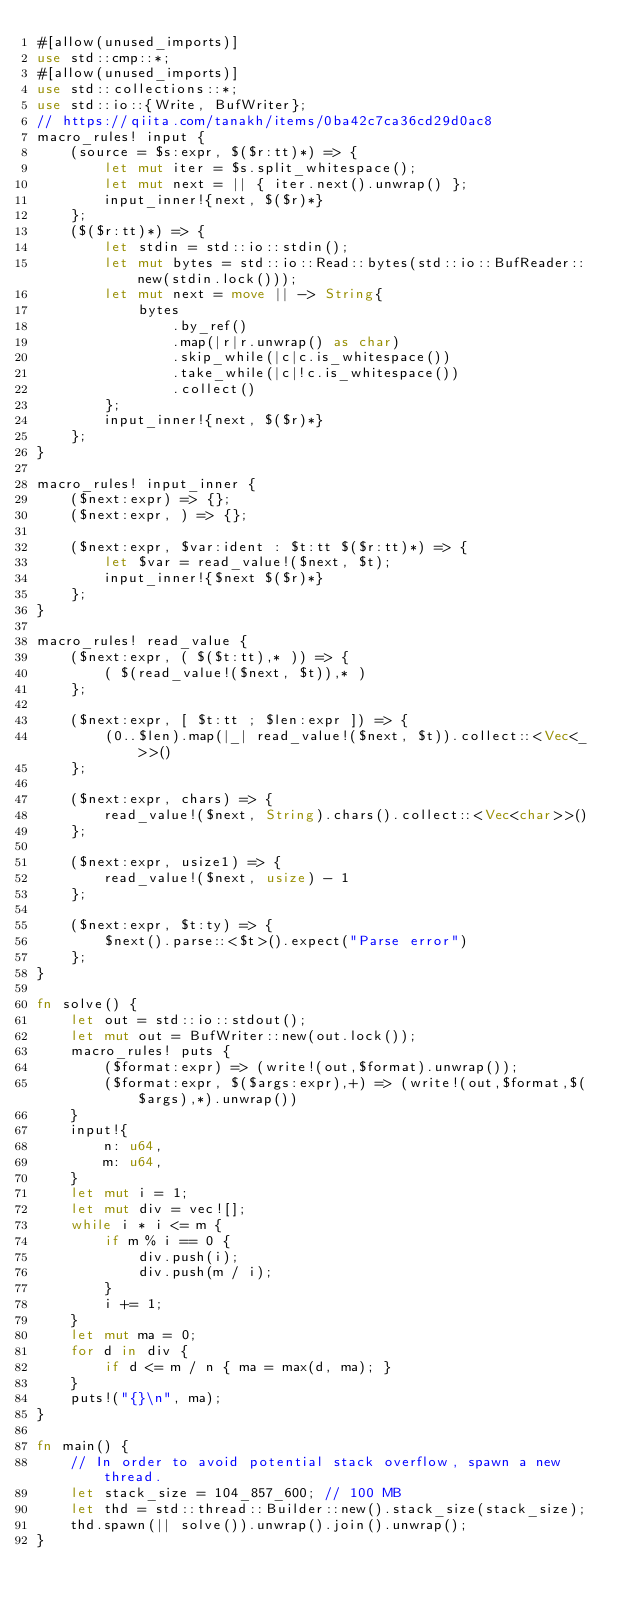Convert code to text. <code><loc_0><loc_0><loc_500><loc_500><_Rust_>#[allow(unused_imports)]
use std::cmp::*;
#[allow(unused_imports)]
use std::collections::*;
use std::io::{Write, BufWriter};
// https://qiita.com/tanakh/items/0ba42c7ca36cd29d0ac8
macro_rules! input {
    (source = $s:expr, $($r:tt)*) => {
        let mut iter = $s.split_whitespace();
        let mut next = || { iter.next().unwrap() };
        input_inner!{next, $($r)*}
    };
    ($($r:tt)*) => {
        let stdin = std::io::stdin();
        let mut bytes = std::io::Read::bytes(std::io::BufReader::new(stdin.lock()));
        let mut next = move || -> String{
            bytes
                .by_ref()
                .map(|r|r.unwrap() as char)
                .skip_while(|c|c.is_whitespace())
                .take_while(|c|!c.is_whitespace())
                .collect()
        };
        input_inner!{next, $($r)*}
    };
}

macro_rules! input_inner {
    ($next:expr) => {};
    ($next:expr, ) => {};

    ($next:expr, $var:ident : $t:tt $($r:tt)*) => {
        let $var = read_value!($next, $t);
        input_inner!{$next $($r)*}
    };
}

macro_rules! read_value {
    ($next:expr, ( $($t:tt),* )) => {
        ( $(read_value!($next, $t)),* )
    };

    ($next:expr, [ $t:tt ; $len:expr ]) => {
        (0..$len).map(|_| read_value!($next, $t)).collect::<Vec<_>>()
    };

    ($next:expr, chars) => {
        read_value!($next, String).chars().collect::<Vec<char>>()
    };

    ($next:expr, usize1) => {
        read_value!($next, usize) - 1
    };

    ($next:expr, $t:ty) => {
        $next().parse::<$t>().expect("Parse error")
    };
}

fn solve() {
    let out = std::io::stdout();
    let mut out = BufWriter::new(out.lock());
    macro_rules! puts {
        ($format:expr) => (write!(out,$format).unwrap());
        ($format:expr, $($args:expr),+) => (write!(out,$format,$($args),*).unwrap())
    }
    input!{
        n: u64,
        m: u64,
    }
    let mut i = 1;
    let mut div = vec![];
    while i * i <= m {
        if m % i == 0 {
            div.push(i);
            div.push(m / i);
        }
        i += 1;
    }
    let mut ma = 0;
    for d in div {
        if d <= m / n { ma = max(d, ma); }
    }
    puts!("{}\n", ma);
}

fn main() {
    // In order to avoid potential stack overflow, spawn a new thread.
    let stack_size = 104_857_600; // 100 MB
    let thd = std::thread::Builder::new().stack_size(stack_size);
    thd.spawn(|| solve()).unwrap().join().unwrap();
}
</code> 